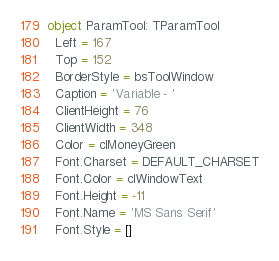Convert code to text. <code><loc_0><loc_0><loc_500><loc_500><_Pascal_>object ParamTool: TParamTool
  Left = 167
  Top = 152
  BorderStyle = bsToolWindow
  Caption = 'Variable - '
  ClientHeight = 76
  ClientWidth = 348
  Color = clMoneyGreen
  Font.Charset = DEFAULT_CHARSET
  Font.Color = clWindowText
  Font.Height = -11
  Font.Name = 'MS Sans Serif'
  Font.Style = []</code> 